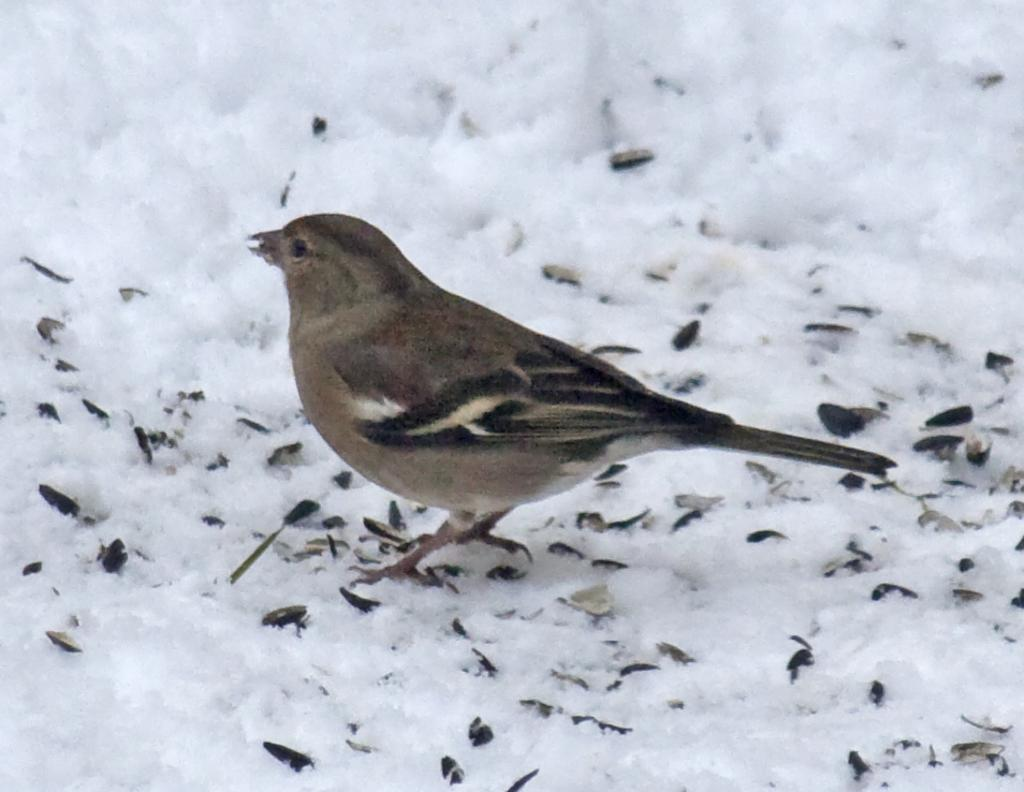What type of animal is in the image? There is a bird in the image. What colors can be seen on the bird? The bird is black and brown in color. Where is the bird located in the image? The bird is on the snow. What other objects are on the snow in the image? There are black and cream color objects on the snow. What type of cloth is being used to cover the dime in the image? There is no cloth or dime present in the image; it features a bird on the snow with black and cream color objects. 